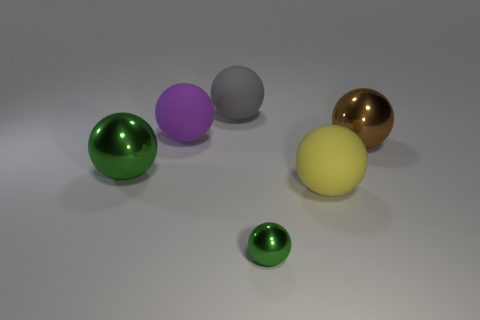Subtract all brown balls. How many balls are left? 5 Subtract all brown metallic balls. How many balls are left? 5 Subtract all cyan spheres. Subtract all cyan cylinders. How many spheres are left? 6 Add 1 brown shiny balls. How many objects exist? 7 Subtract all large brown shiny spheres. Subtract all large matte spheres. How many objects are left? 2 Add 2 large gray balls. How many large gray balls are left? 3 Add 5 yellow metal cylinders. How many yellow metal cylinders exist? 5 Subtract 0 red blocks. How many objects are left? 6 